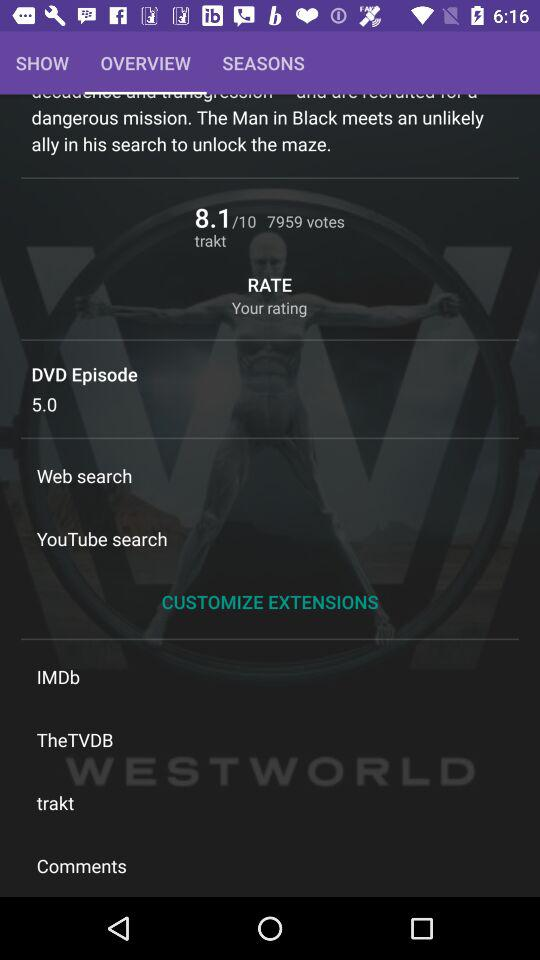What is the given number of DVD episodes? The given number of DVD episodes is 5.0. 